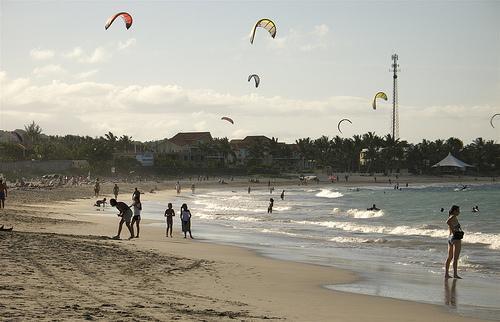How many tall structures are in the photo?
Give a very brief answer. 1. How many radio towers can be seen?
Give a very brief answer. 1. How many people can be seen wearing orange?
Give a very brief answer. 0. How many people are driving motors at the beach?
Give a very brief answer. 0. 